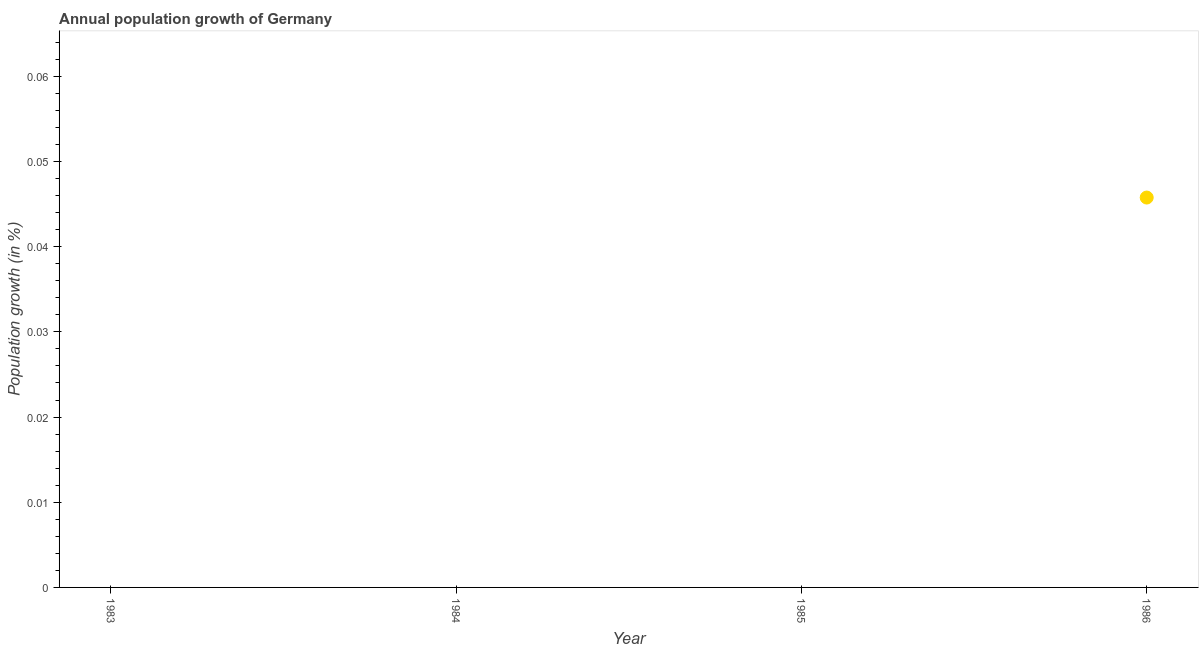Across all years, what is the maximum population growth?
Your response must be concise. 0.05. In which year was the population growth maximum?
Offer a terse response. 1986. What is the sum of the population growth?
Ensure brevity in your answer.  0.05. What is the average population growth per year?
Your answer should be compact. 0.01. What is the difference between the highest and the lowest population growth?
Your response must be concise. 0.05. Does the population growth monotonically increase over the years?
Your answer should be compact. No. What is the difference between two consecutive major ticks on the Y-axis?
Keep it short and to the point. 0.01. Are the values on the major ticks of Y-axis written in scientific E-notation?
Provide a short and direct response. No. What is the title of the graph?
Provide a succinct answer. Annual population growth of Germany. What is the label or title of the X-axis?
Offer a very short reply. Year. What is the label or title of the Y-axis?
Make the answer very short. Population growth (in %). What is the Population growth (in %) in 1984?
Give a very brief answer. 0. What is the Population growth (in %) in 1985?
Provide a short and direct response. 0. What is the Population growth (in %) in 1986?
Offer a very short reply. 0.05. 